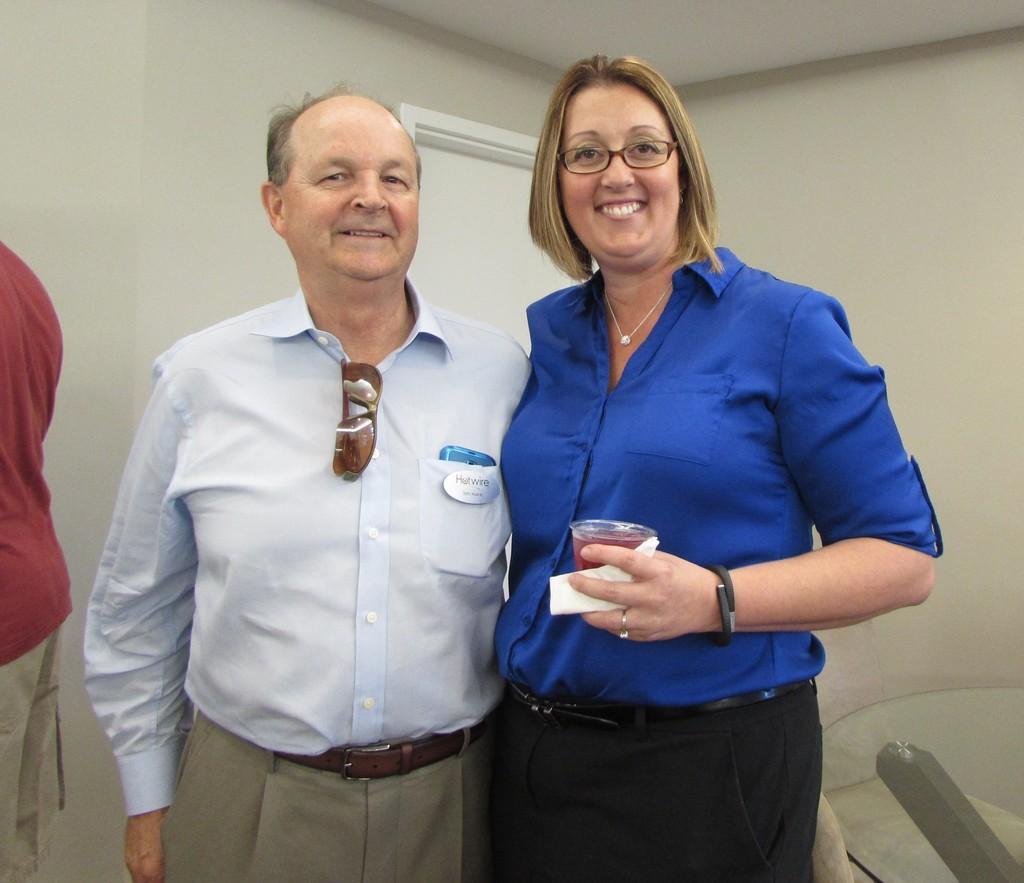How would you summarize this image in a sentence or two? In this image I can see two people are standing and I can see smile on their faces. Here I can see she is wearing specs and holding a glass. I can also see both of them are wearing formal dress and over here I can see one more person in red dress. 